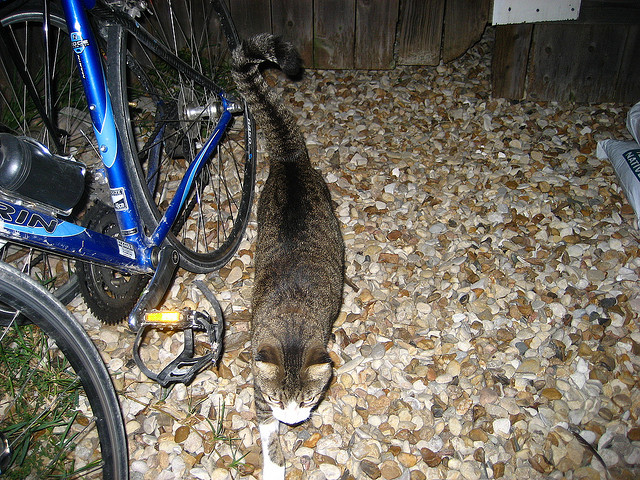Please identify all text content in this image. RIN NATIV 